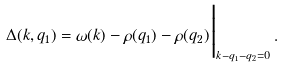Convert formula to latex. <formula><loc_0><loc_0><loc_500><loc_500>\Delta ( { k } , { q } _ { 1 } ) = \omega ( { k } ) - \rho ( { q } _ { 1 } ) - \rho ( { q } _ { 2 } ) \Big | _ { { k } - { q } _ { 1 } - { q } _ { 2 } = 0 } \, .</formula> 